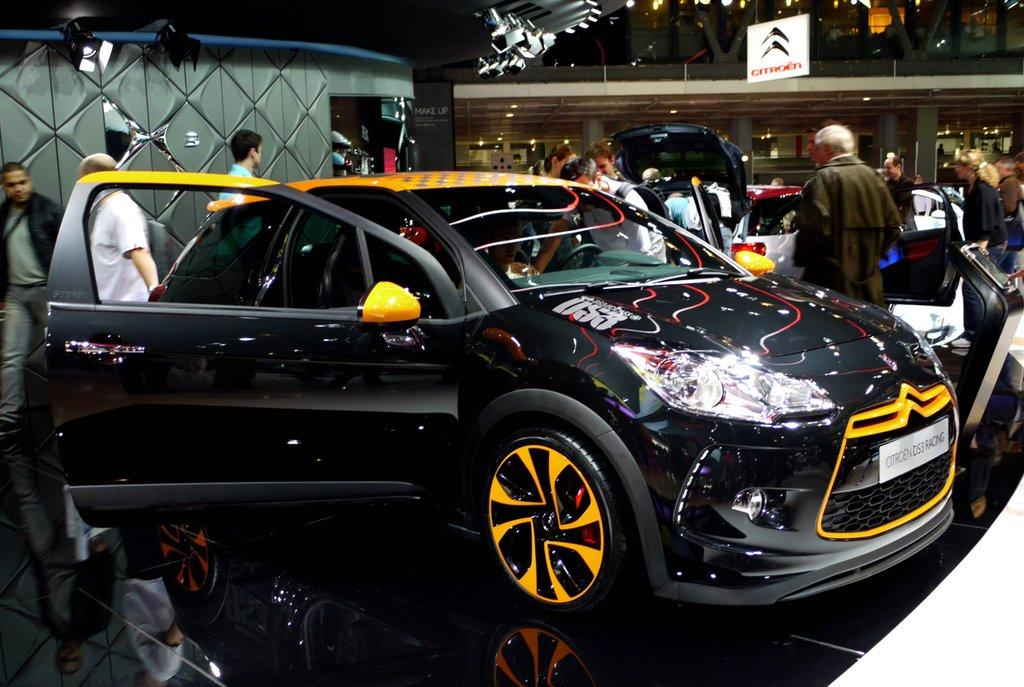What type of location is depicted in the image? The image shows an inside view of a mall. What can be seen outside the mall in the image? There are cars visible in the image. Are there any people present in the image? Yes, there are people in the image. What type of lighting is present in the image? There are lights in the image. How does the mall trip crush the person's spirit in the image? There is no indication in the image that the mall trip has crushed anyone's spirit, and the image does not show any emotional reactions. 